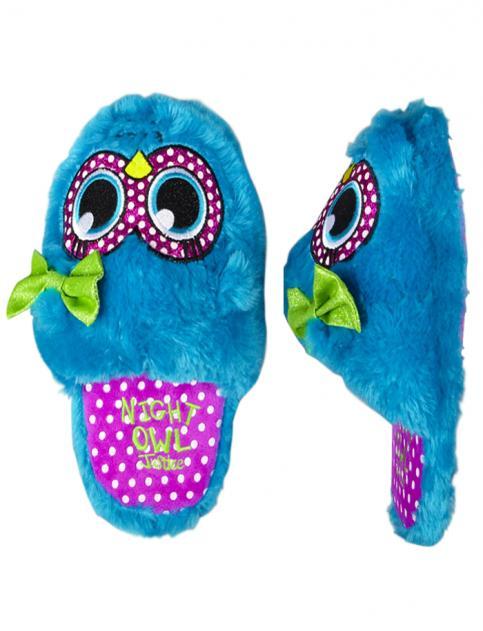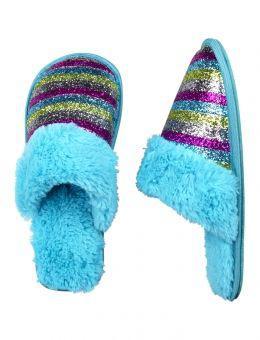The first image is the image on the left, the second image is the image on the right. Evaluate the accuracy of this statement regarding the images: "The left image contains a single print-patterned slipper without a fluffy texture, and the right image contains a pair of fluffy slippers.". Is it true? Answer yes or no. No. The first image is the image on the left, the second image is the image on the right. Considering the images on both sides, is "there is a pair of slippers with on on its side, with eyes on the front" valid? Answer yes or no. Yes. 